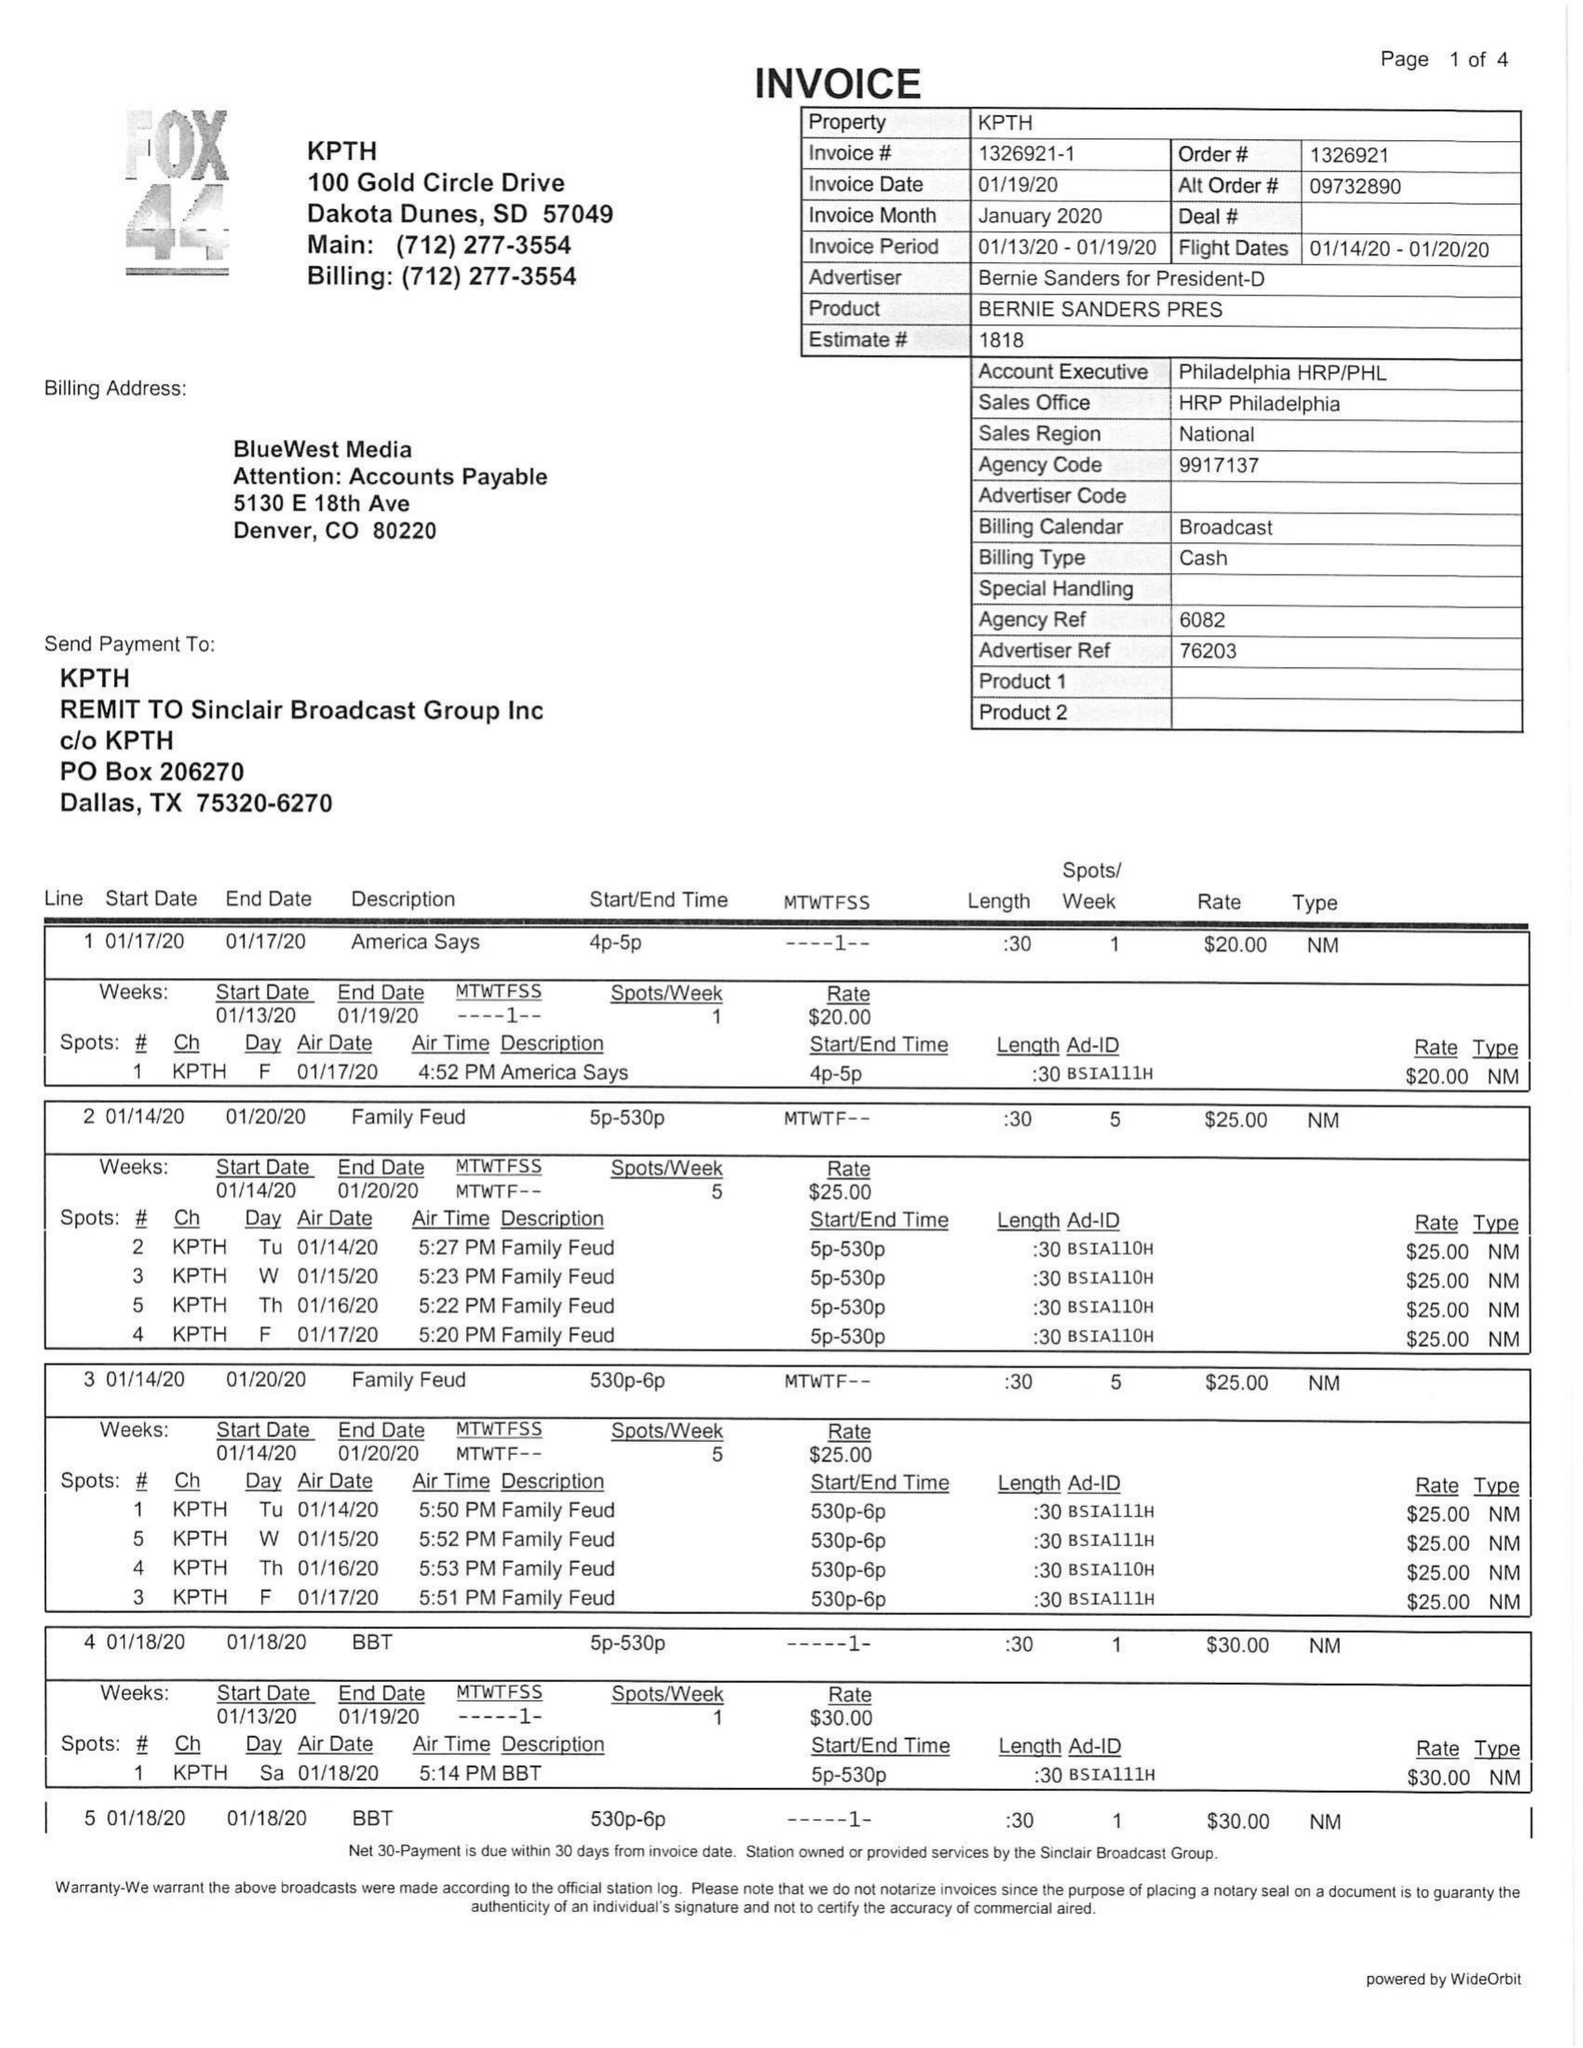What is the value for the flight_to?
Answer the question using a single word or phrase. 01/20/20 